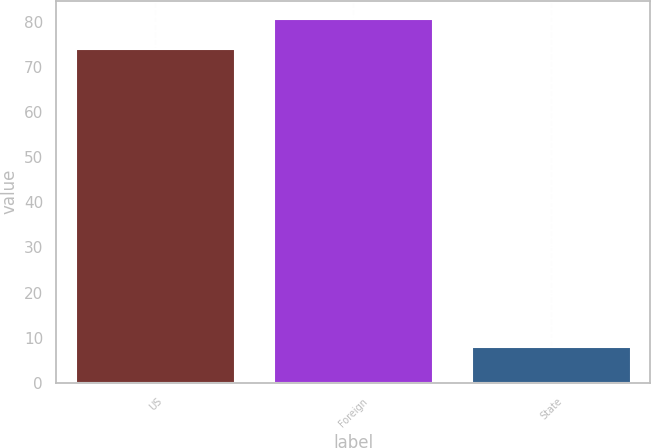Convert chart. <chart><loc_0><loc_0><loc_500><loc_500><bar_chart><fcel>US<fcel>Foreign<fcel>State<nl><fcel>74<fcel>80.7<fcel>8<nl></chart> 